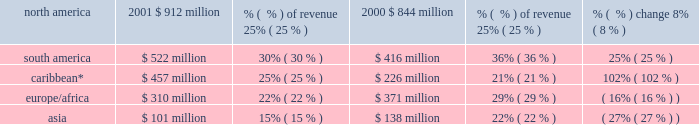Of sales , competitive supply gross margin declined in south america , europe/africa and the caribbean and remained relatively flat in north america and asia .
Large utilities gross margin increased $ 201 million , or 37% ( 37 % ) , to $ 739 million in 2001 from $ 538 million in 2000 .
Excluding businesses acquired or that commenced commercial operations during 2001 and 2000 , large utilities gross margin increased 10% ( 10 % ) to $ 396 million in 2001 .
Large utilities gross margin as a percentage of revenues increased to 30% ( 30 % ) in 2001 from 25% ( 25 % ) in 2000 .
In the caribbean ( which includes venezuela ) , large utility gross margin increased $ 166 million and was due to a full year of contribution from edc which was acquired in june 2000 .
Also , in north america , the gross margin contributions from both ipalco and cilcorp increased .
Growth distribution gross margin increased $ 165 million , or 126% ( 126 % ) to $ 296 million in 2001 from $ 131 million in 2000 .
Excluding businesses acquired during 2001 and 2000 , growth distribution gross margin increased 93% ( 93 % ) to $ 268 million in 2001 .
Growth distribution gross margin as a percentage of revenue increased to 18% ( 18 % ) in 2001 from 10% ( 10 % ) in 2000 .
Growth distribution business gross margin , as well as gross margin as a percentage of sales , increased in south america and the caribbean , but decreased in europe/africa and asia .
In south america , growth distribution margin increased $ 157 million and was 38% ( 38 % ) of revenues .
The increase is due primarily to sul 2019s sales of excess energy into the southeast market where rationing was taking place .
In the caribbean , growth distribution margin increased $ 39 million and was 5% ( 5 % ) of revenues .
The increase is due mainly to lower losses at ede este and an increase in contribution from caess .
In europe/africa , growth distribution margin decreased $ 10 million and was negative due to losses at sonel .
In asia , growth distribution margin decreased $ 18 million and was negative due primarily to an increase in losses at telasi .
The breakdown of aes 2019s gross margin for the years ended december 31 , 2001 and 2000 , based on the geographic region in which they were earned , is set forth below. .
* includes venezuela and colombia .
Selling , general and administrative expenses selling , general and administrative expenses increased $ 38 million , or 46% ( 46 % ) , to $ 120 million in 2001 from $ 82 million in 2000 .
Selling , general and administrative expenses as a percentage of revenues remained constant at 1% ( 1 % ) in 2001 and 2000 .
The overall increase in selling , general and administrative expenses is due to increased development activities .
Interest expense , net net interest expense increased $ 327 million , or 29% ( 29 % ) , to $ 1.5 billion in 2001 from $ 1.1 billion in 2000 .
Net interest expense as a percentage of revenues increased to 16% ( 16 % ) in 2001 from 15% ( 15 % ) in 2000 .
Net interest expense increased overall primarily due to interest expense at new businesses , additional corporate interest expense arising from senior debt issued during 2001 to finance new investments and mark-to-market losses on interest rate related derivative instruments. .
2001 north american revenues were what in millions? 
Computations: (912 / 25%)
Answer: 3648.0. Of sales , competitive supply gross margin declined in south america , europe/africa and the caribbean and remained relatively flat in north america and asia .
Large utilities gross margin increased $ 201 million , or 37% ( 37 % ) , to $ 739 million in 2001 from $ 538 million in 2000 .
Excluding businesses acquired or that commenced commercial operations during 2001 and 2000 , large utilities gross margin increased 10% ( 10 % ) to $ 396 million in 2001 .
Large utilities gross margin as a percentage of revenues increased to 30% ( 30 % ) in 2001 from 25% ( 25 % ) in 2000 .
In the caribbean ( which includes venezuela ) , large utility gross margin increased $ 166 million and was due to a full year of contribution from edc which was acquired in june 2000 .
Also , in north america , the gross margin contributions from both ipalco and cilcorp increased .
Growth distribution gross margin increased $ 165 million , or 126% ( 126 % ) to $ 296 million in 2001 from $ 131 million in 2000 .
Excluding businesses acquired during 2001 and 2000 , growth distribution gross margin increased 93% ( 93 % ) to $ 268 million in 2001 .
Growth distribution gross margin as a percentage of revenue increased to 18% ( 18 % ) in 2001 from 10% ( 10 % ) in 2000 .
Growth distribution business gross margin , as well as gross margin as a percentage of sales , increased in south america and the caribbean , but decreased in europe/africa and asia .
In south america , growth distribution margin increased $ 157 million and was 38% ( 38 % ) of revenues .
The increase is due primarily to sul 2019s sales of excess energy into the southeast market where rationing was taking place .
In the caribbean , growth distribution margin increased $ 39 million and was 5% ( 5 % ) of revenues .
The increase is due mainly to lower losses at ede este and an increase in contribution from caess .
In europe/africa , growth distribution margin decreased $ 10 million and was negative due to losses at sonel .
In asia , growth distribution margin decreased $ 18 million and was negative due primarily to an increase in losses at telasi .
The breakdown of aes 2019s gross margin for the years ended december 31 , 2001 and 2000 , based on the geographic region in which they were earned , is set forth below. .
* includes venezuela and colombia .
Selling , general and administrative expenses selling , general and administrative expenses increased $ 38 million , or 46% ( 46 % ) , to $ 120 million in 2001 from $ 82 million in 2000 .
Selling , general and administrative expenses as a percentage of revenues remained constant at 1% ( 1 % ) in 2001 and 2000 .
The overall increase in selling , general and administrative expenses is due to increased development activities .
Interest expense , net net interest expense increased $ 327 million , or 29% ( 29 % ) , to $ 1.5 billion in 2001 from $ 1.1 billion in 2000 .
Net interest expense as a percentage of revenues increased to 16% ( 16 % ) in 2001 from 15% ( 15 % ) in 2000 .
Net interest expense increased overall primarily due to interest expense at new businesses , additional corporate interest expense arising from senior debt issued during 2001 to finance new investments and mark-to-market losses on interest rate related derivative instruments. .
2001 south american revenues were what in millions? 
Computations: (522 / 30%)
Answer: 1740.0. 